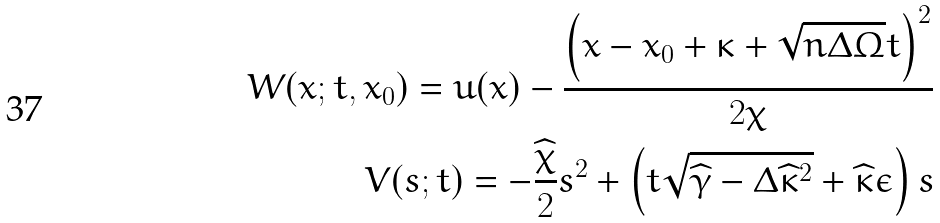<formula> <loc_0><loc_0><loc_500><loc_500>W ( x ; t , x _ { 0 } ) = u ( x ) - \frac { \left ( x - x _ { 0 } + \kappa + \sqrt { n \Delta \Omega } t \right ) ^ { 2 } } { 2 \chi } \\ V ( s ; t ) = - \frac { \widehat { \chi } } { 2 } s ^ { 2 } + \left ( t \sqrt { \widehat { \gamma } - \Delta \widehat { \kappa } ^ { 2 } } + \widehat { \kappa } \epsilon \right ) s</formula> 